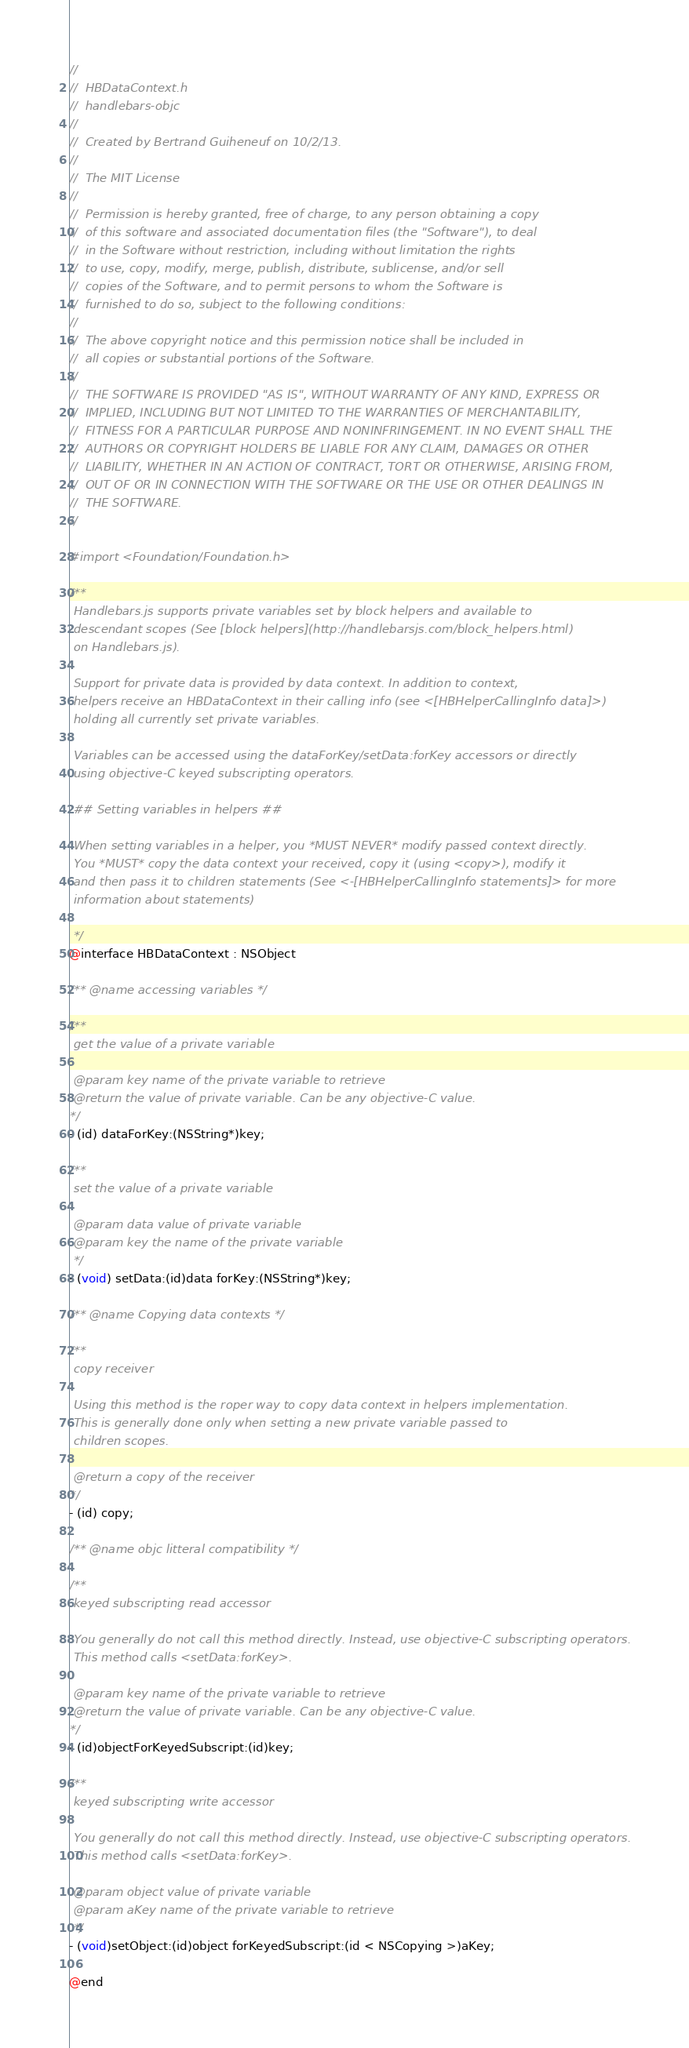Convert code to text. <code><loc_0><loc_0><loc_500><loc_500><_C_>//
//  HBDataContext.h
//  handlebars-objc
//
//  Created by Bertrand Guiheneuf on 10/2/13.
//
//  The MIT License
//
//  Permission is hereby granted, free of charge, to any person obtaining a copy
//  of this software and associated documentation files (the "Software"), to deal
//  in the Software without restriction, including without limitation the rights
//  to use, copy, modify, merge, publish, distribute, sublicense, and/or sell
//  copies of the Software, and to permit persons to whom the Software is
//  furnished to do so, subject to the following conditions:
//
//  The above copyright notice and this permission notice shall be included in
//  all copies or substantial portions of the Software.
//
//  THE SOFTWARE IS PROVIDED "AS IS", WITHOUT WARRANTY OF ANY KIND, EXPRESS OR
//  IMPLIED, INCLUDING BUT NOT LIMITED TO THE WARRANTIES OF MERCHANTABILITY,
//  FITNESS FOR A PARTICULAR PURPOSE AND NONINFRINGEMENT. IN NO EVENT SHALL THE
//  AUTHORS OR COPYRIGHT HOLDERS BE LIABLE FOR ANY CLAIM, DAMAGES OR OTHER
//  LIABILITY, WHETHER IN AN ACTION OF CONTRACT, TORT OR OTHERWISE, ARISING FROM,
//  OUT OF OR IN CONNECTION WITH THE SOFTWARE OR THE USE OR OTHER DEALINGS IN
//  THE SOFTWARE.
//

#import <Foundation/Foundation.h>

/**
 Handlebars.js supports private variables set by block helpers and available to 
 descendant scopes (See [block helpers](http://handlebarsjs.com/block_helpers.html)
 on Handlebars.js).
 
 Support for private data is provided by data context. In addition to context, 
 helpers receive an HBDataContext in their calling info (see <[HBHelperCallingInfo data]>)
 holding all currently set private variables. 
 
 Variables can be accessed using the dataForKey/setData:forKey accessors or directly 
 using objective-C keyed subscripting operators. 
 
 ## Setting variables in helpers ##
 
 When setting variables in a helper, you *MUST NEVER* modify passed context directly.
 You *MUST* copy the data context your received, copy it (using <copy>), modify it
 and then pass it to children statements (See <-[HBHelperCallingInfo statements]> for more
 information about statements)
 
 */
@interface HBDataContext : NSObject

/** @name accessing variables */

/**
 get the value of a private variable
 
 @param key name of the private variable to retrieve
 @return the value of private variable. Can be any objective-C value.
*/
- (id) dataForKey:(NSString*)key;

/**
 set the value of a private variable
 
 @param data value of private variable 
 @param key the name of the private variable
 */
- (void) setData:(id)data forKey:(NSString*)key;

/** @name Copying data contexts */

/**
 copy receiver
 
 Using this method is the roper way to copy data context in helpers implementation. 
 This is generally done only when setting a new private variable passed to 
 children scopes. 
 
 @return a copy of the receiver
*/
- (id) copy; 

/** @name objc litteral compatibility */

/** 
 keyed subscripting read accessor 
 
 You generally do not call this method directly. Instead, use objective-C subscripting operators.
 This method calls <setData:forKey>. 
 
 @param key name of the private variable to retrieve
 @return the value of private variable. Can be any objective-C value.
*/
- (id)objectForKeyedSubscript:(id)key;

/**
 keyed subscripting write accessor
 
 You generally do not call this method directly. Instead, use objective-C subscripting operators.
 This method calls <setData:forKey>.
 
 @param object value of private variable
 @param aKey name of the private variable to retrieve
 */
- (void)setObject:(id)object forKeyedSubscript:(id < NSCopying >)aKey;

@end
</code> 